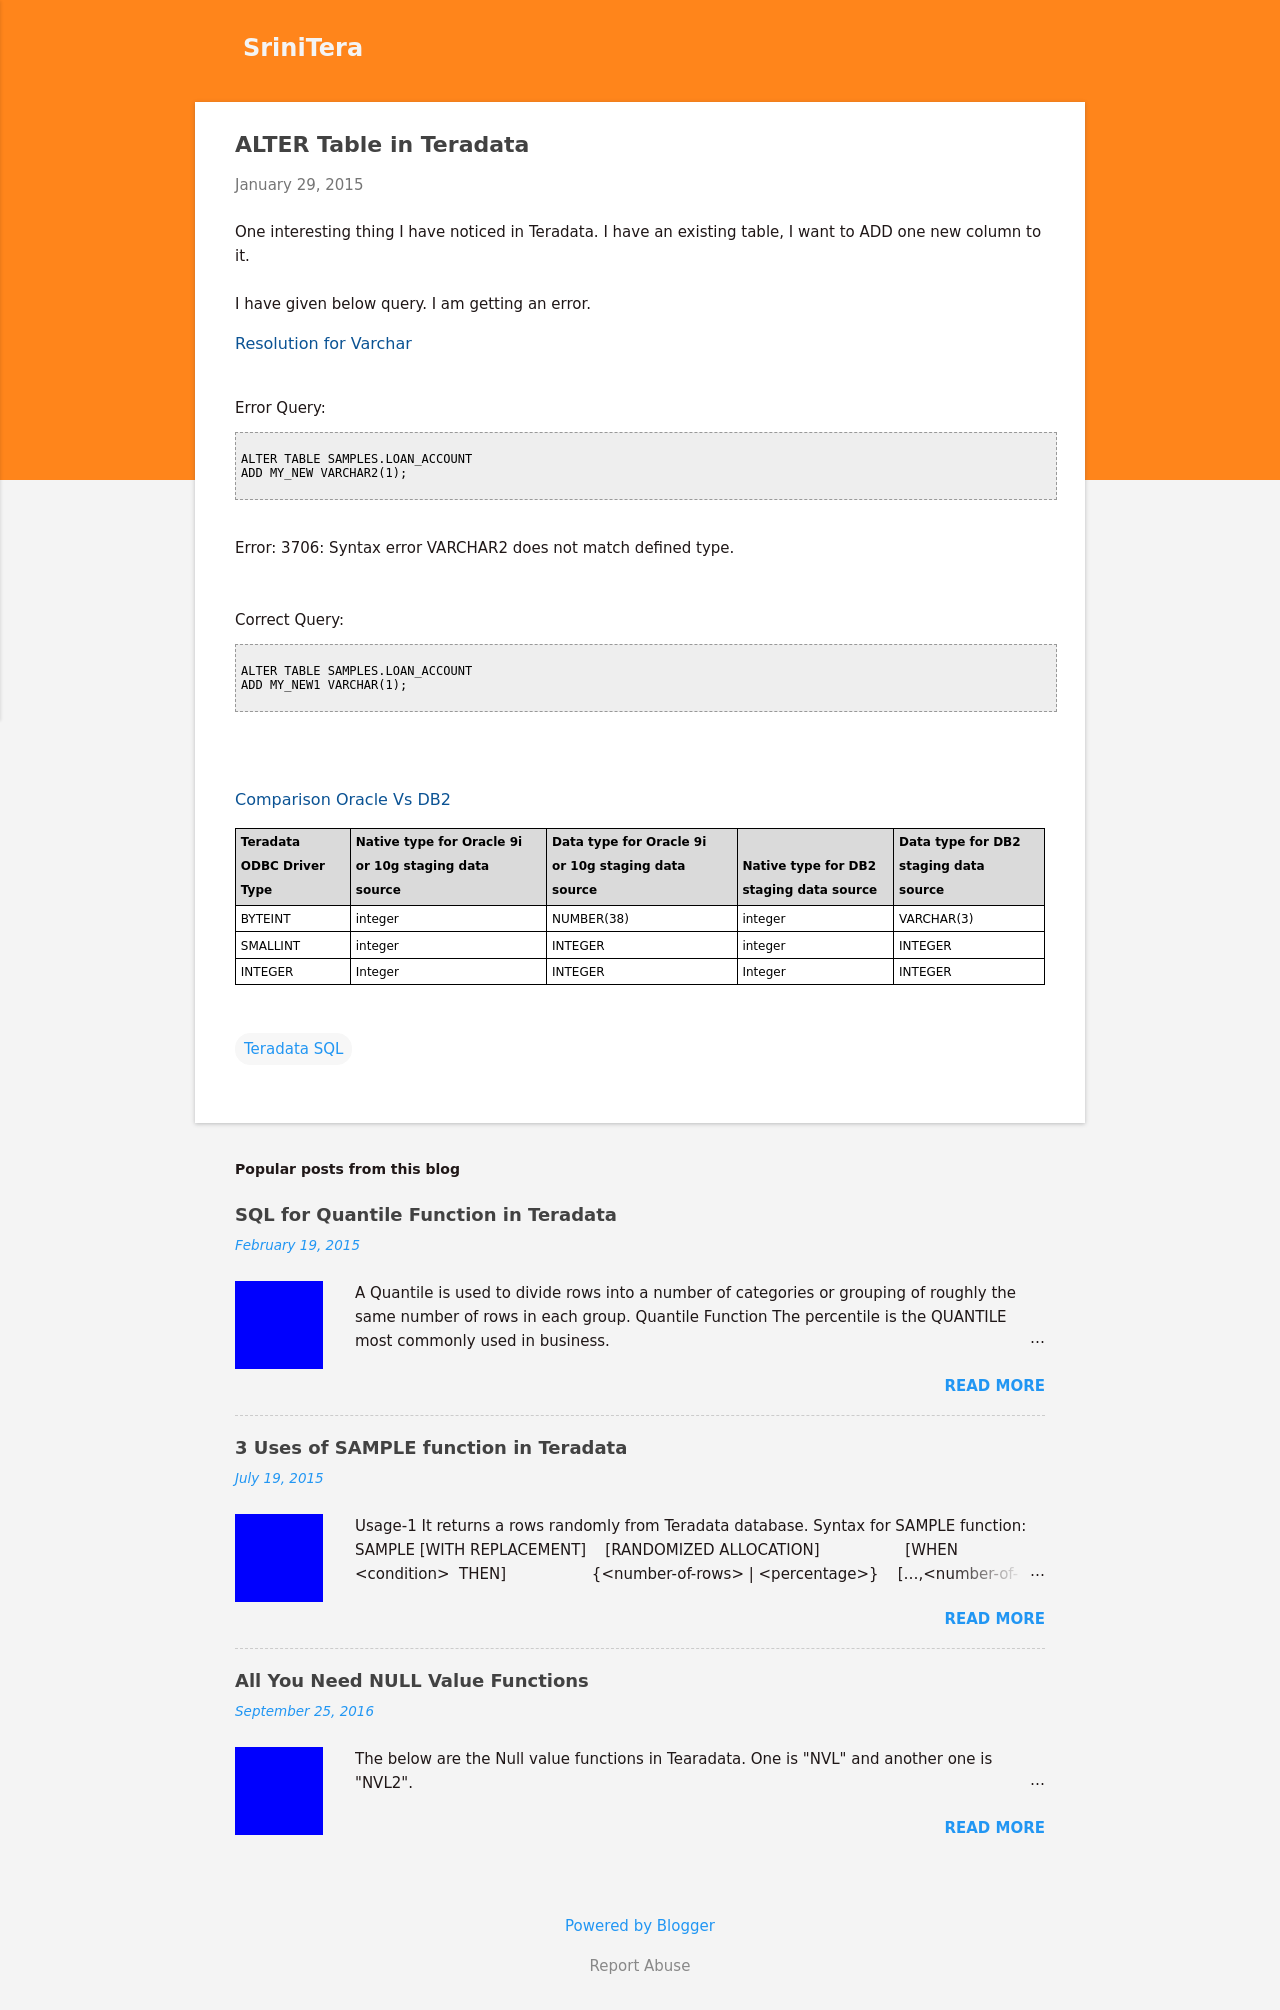Could you guide me through the process of developing this website with HTML? Certainly! To build a website similar to the one displayed in the image, you would use HTML for structuring the website's content and CSS for styling. The HTML could incorporate elements such as <header>, <main>, and <footer> to define sections. CSS would be used to style these sections according to your branding needs, such as setting color schemes, layout adjustments, and responsive designs to ensure the website looks good on both desktops and mobile devices. 